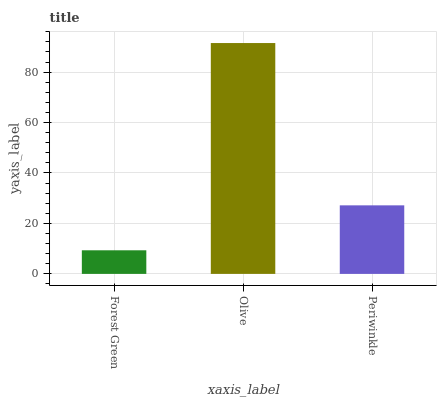Is Periwinkle the minimum?
Answer yes or no. No. Is Periwinkle the maximum?
Answer yes or no. No. Is Olive greater than Periwinkle?
Answer yes or no. Yes. Is Periwinkle less than Olive?
Answer yes or no. Yes. Is Periwinkle greater than Olive?
Answer yes or no. No. Is Olive less than Periwinkle?
Answer yes or no. No. Is Periwinkle the high median?
Answer yes or no. Yes. Is Periwinkle the low median?
Answer yes or no. Yes. Is Olive the high median?
Answer yes or no. No. Is Olive the low median?
Answer yes or no. No. 